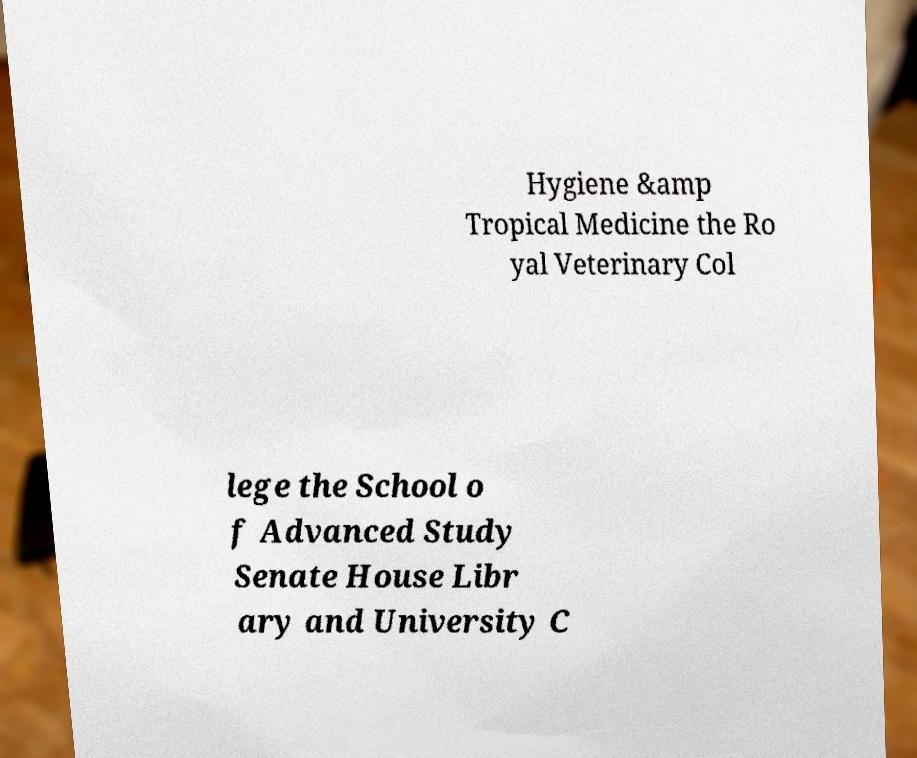What messages or text are displayed in this image? I need them in a readable, typed format. Hygiene &amp Tropical Medicine the Ro yal Veterinary Col lege the School o f Advanced Study Senate House Libr ary and University C 